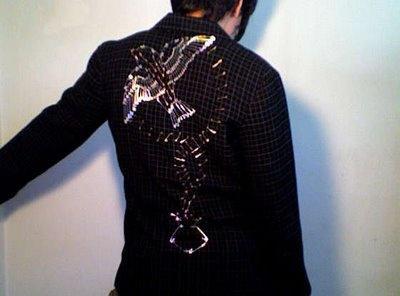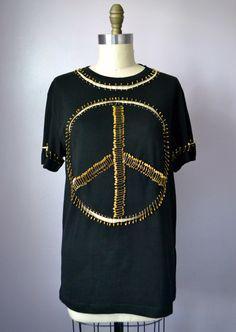The first image is the image on the left, the second image is the image on the right. Examine the images to the left and right. Is the description "There is a black shirt with a peace sign on it and a black collared jacket." accurate? Answer yes or no. Yes. 